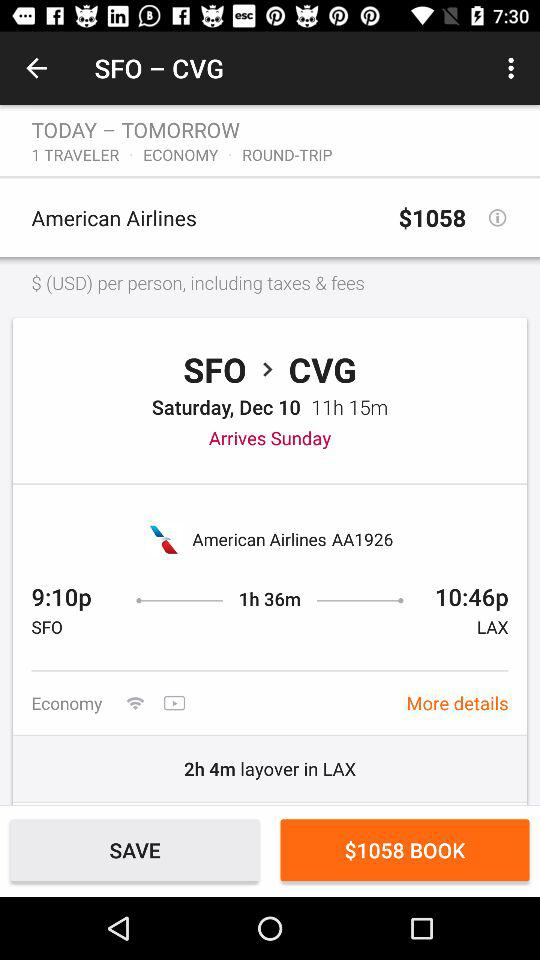What's the departure time? The departure time is 9:10 p.m. 